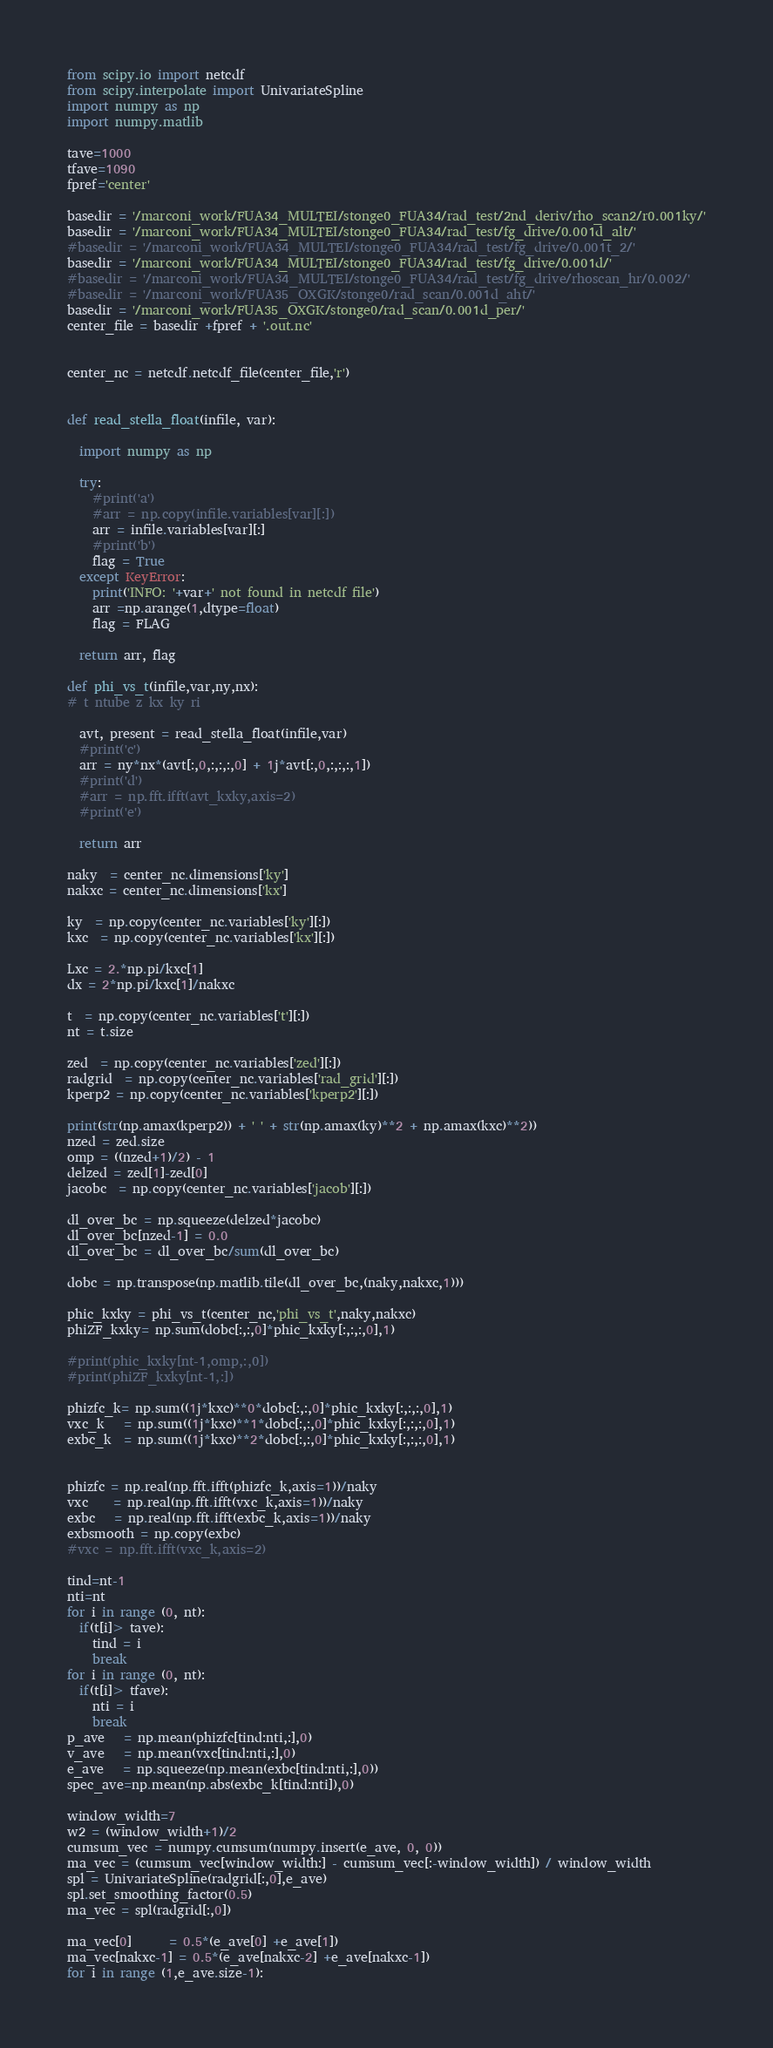<code> <loc_0><loc_0><loc_500><loc_500><_Python_>

from scipy.io import netcdf
from scipy.interpolate import UnivariateSpline
import numpy as np
import numpy.matlib

tave=1000
tfave=1090
fpref='center'

basedir = '/marconi_work/FUA34_MULTEI/stonge0_FUA34/rad_test/2nd_deriv/rho_scan2/r0.001ky/'
basedir = '/marconi_work/FUA34_MULTEI/stonge0_FUA34/rad_test/fg_drive/0.001d_alt/'
#basedir = '/marconi_work/FUA34_MULTEI/stonge0_FUA34/rad_test/fg_drive/0.001t_2/'
basedir = '/marconi_work/FUA34_MULTEI/stonge0_FUA34/rad_test/fg_drive/0.001d/'
#basedir = '/marconi_work/FUA34_MULTEI/stonge0_FUA34/rad_test/fg_drive/rhoscan_hr/0.002/'
#basedir = '/marconi_work/FUA35_OXGK/stonge0/rad_scan/0.001d_aht/'
basedir = '/marconi_work/FUA35_OXGK/stonge0/rad_scan/0.001d_per/'
center_file = basedir +fpref + '.out.nc'


center_nc = netcdf.netcdf_file(center_file,'r')


def read_stella_float(infile, var):

  import numpy as np

  try:
    #print('a')
    #arr = np.copy(infile.variables[var][:])
    arr = infile.variables[var][:]
    #print('b')
    flag = True
  except KeyError:
    print('INFO: '+var+' not found in netcdf file')
    arr =np.arange(1,dtype=float)
    flag = FLAG

  return arr, flag

def phi_vs_t(infile,var,ny,nx):
# t ntube z kx ky ri

  avt, present = read_stella_float(infile,var)
  #print('c')
  arr = ny*nx*(avt[:,0,:,:,:,0] + 1j*avt[:,0,:,:,:,1])
  #print('d')
  #arr = np.fft.ifft(avt_kxky,axis=2)
  #print('e')

  return arr

naky  = center_nc.dimensions['ky']
nakxc = center_nc.dimensions['kx']

ky  = np.copy(center_nc.variables['ky'][:])
kxc  = np.copy(center_nc.variables['kx'][:])

Lxc = 2.*np.pi/kxc[1]
dx = 2*np.pi/kxc[1]/nakxc

t  = np.copy(center_nc.variables['t'][:])
nt = t.size

zed  = np.copy(center_nc.variables['zed'][:])
radgrid  = np.copy(center_nc.variables['rad_grid'][:])
kperp2 = np.copy(center_nc.variables['kperp2'][:])

print(str(np.amax(kperp2)) + ' ' + str(np.amax(ky)**2 + np.amax(kxc)**2))
nzed = zed.size
omp = ((nzed+1)/2) - 1
delzed = zed[1]-zed[0]
jacobc  = np.copy(center_nc.variables['jacob'][:])

dl_over_bc = np.squeeze(delzed*jacobc)
dl_over_bc[nzed-1] = 0.0
dl_over_bc = dl_over_bc/sum(dl_over_bc)

dobc = np.transpose(np.matlib.tile(dl_over_bc,(naky,nakxc,1)))

phic_kxky = phi_vs_t(center_nc,'phi_vs_t',naky,nakxc)
phiZF_kxky= np.sum(dobc[:,:,0]*phic_kxky[:,:,:,0],1)

#print(phic_kxky[nt-1,omp,:,0])
#print(phiZF_kxky[nt-1,:])

phizfc_k= np.sum((1j*kxc)**0*dobc[:,:,0]*phic_kxky[:,:,:,0],1)
vxc_k   = np.sum((1j*kxc)**1*dobc[:,:,0]*phic_kxky[:,:,:,0],1)
exbc_k  = np.sum((1j*kxc)**2*dobc[:,:,0]*phic_kxky[:,:,:,0],1)


phizfc = np.real(np.fft.ifft(phizfc_k,axis=1))/naky
vxc    = np.real(np.fft.ifft(vxc_k,axis=1))/naky
exbc   = np.real(np.fft.ifft(exbc_k,axis=1))/naky
exbsmooth = np.copy(exbc)
#vxc = np.fft.ifft(vxc_k,axis=2)

tind=nt-1
nti=nt
for i in range (0, nt):
  if(t[i]> tave):
    tind = i
    break
for i in range (0, nt):
  if(t[i]> tfave):
    nti = i
    break
p_ave   = np.mean(phizfc[tind:nti,:],0)
v_ave   = np.mean(vxc[tind:nti,:],0)
e_ave   = np.squeeze(np.mean(exbc[tind:nti,:],0))
spec_ave=np.mean(np.abs(exbc_k[tind:nti]),0)

window_width=7
w2 = (window_width+1)/2
cumsum_vec = numpy.cumsum(numpy.insert(e_ave, 0, 0))
ma_vec = (cumsum_vec[window_width:] - cumsum_vec[:-window_width]) / window_width
spl = UnivariateSpline(radgrid[:,0],e_ave)
spl.set_smoothing_factor(0.5)
ma_vec = spl(radgrid[:,0])

ma_vec[0]      = 0.5*(e_ave[0] +e_ave[1]) 
ma_vec[nakxc-1] = 0.5*(e_ave[nakxc-2] +e_ave[nakxc-1]) 
for i in range (1,e_ave.size-1):</code> 